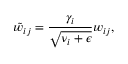<formula> <loc_0><loc_0><loc_500><loc_500>\tilde { w } _ { i j } = \frac { \gamma _ { i } } { \sqrt { \nu _ { i } + \epsilon } } w _ { i j } ,</formula> 